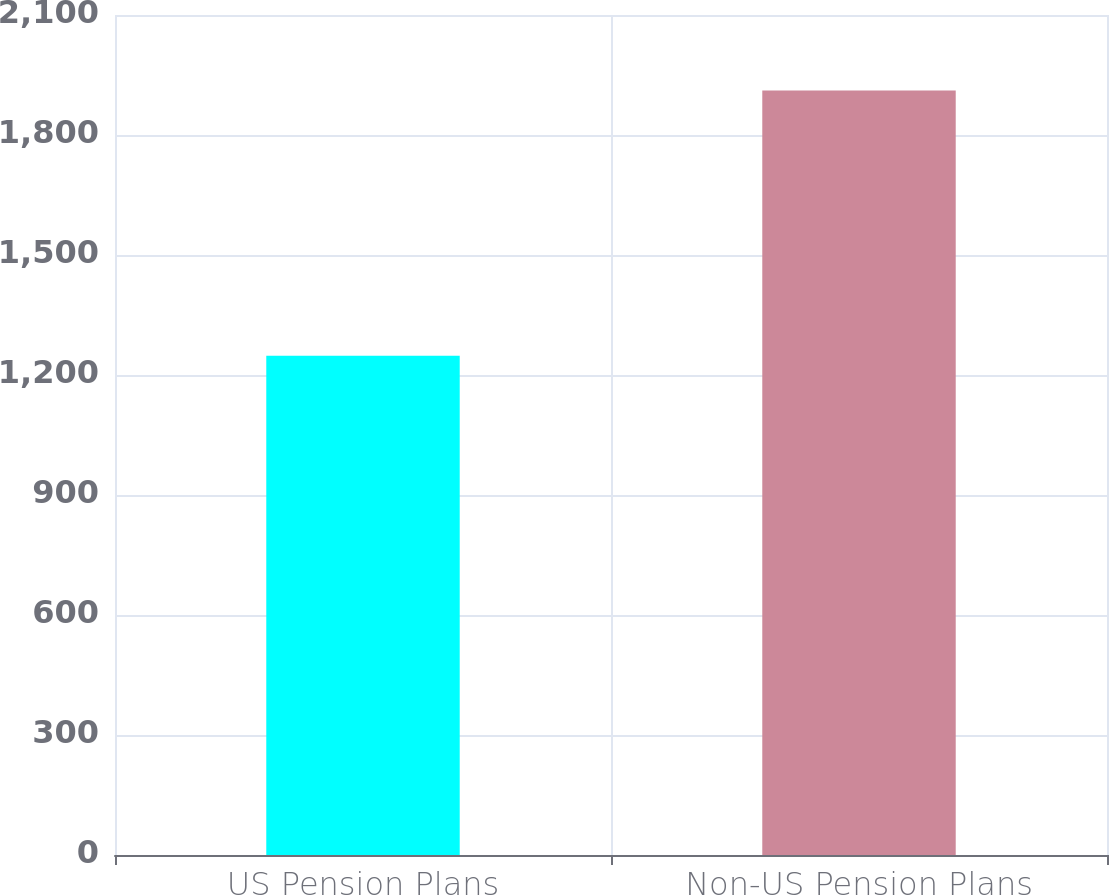<chart> <loc_0><loc_0><loc_500><loc_500><bar_chart><fcel>US Pension Plans<fcel>Non-US Pension Plans<nl><fcel>1248<fcel>1911<nl></chart> 